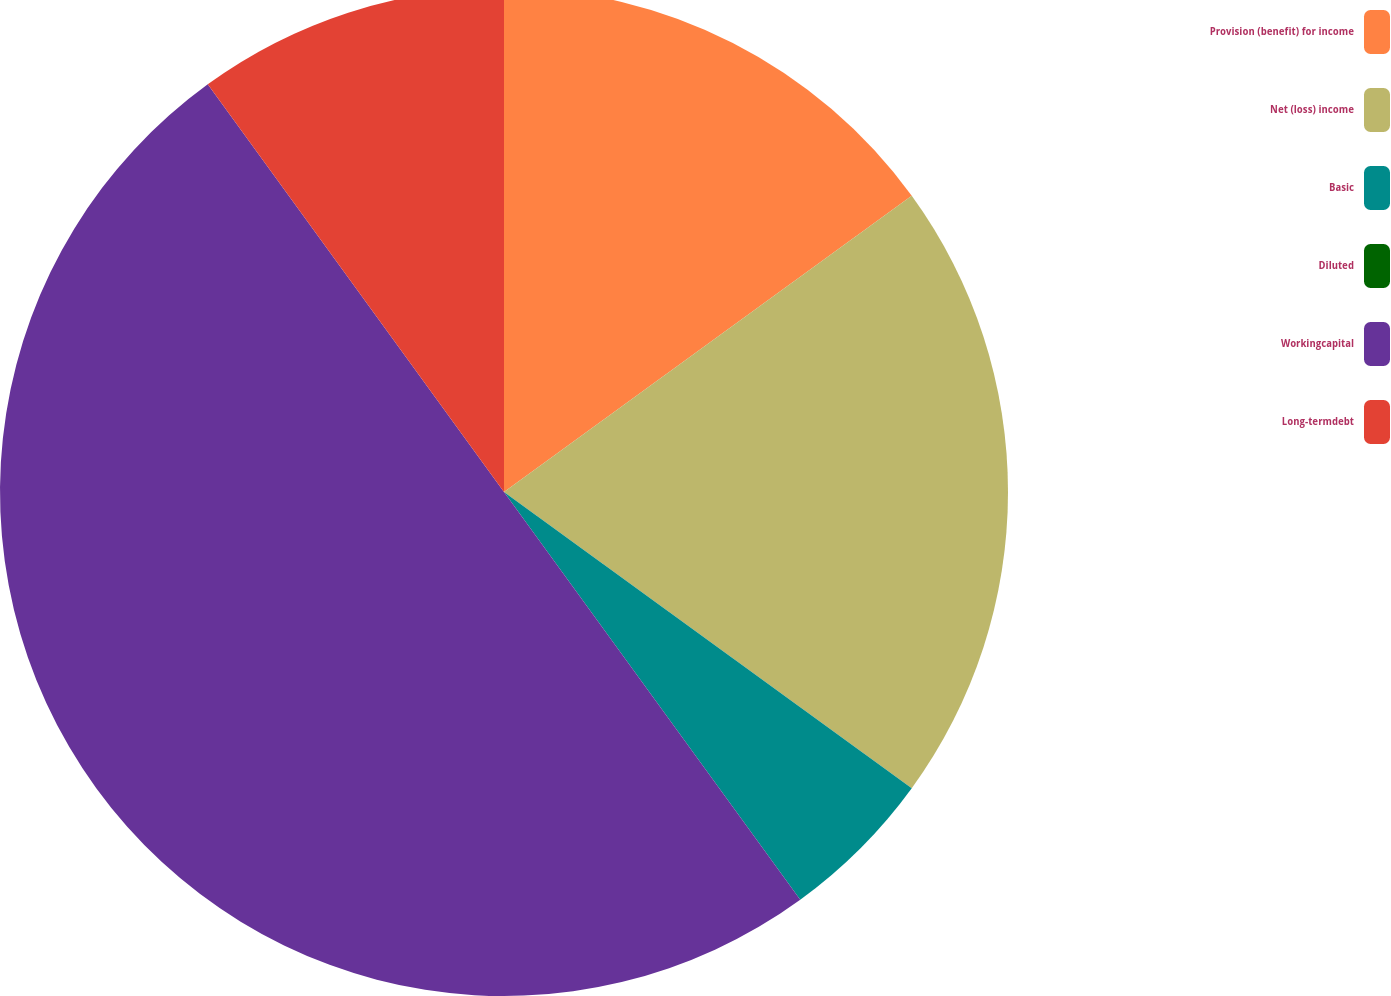<chart> <loc_0><loc_0><loc_500><loc_500><pie_chart><fcel>Provision (benefit) for income<fcel>Net (loss) income<fcel>Basic<fcel>Diluted<fcel>Workingcapital<fcel>Long-termdebt<nl><fcel>15.0%<fcel>20.0%<fcel>5.0%<fcel>0.0%<fcel>50.0%<fcel>10.0%<nl></chart> 